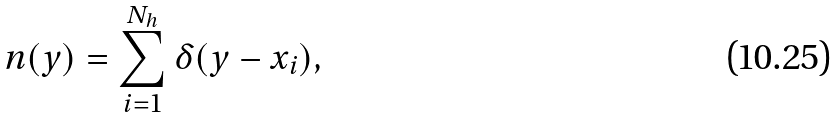<formula> <loc_0><loc_0><loc_500><loc_500>n ( y ) = \sum _ { i = 1 } ^ { N _ { h } } \delta ( y - x _ { i } ) ,</formula> 